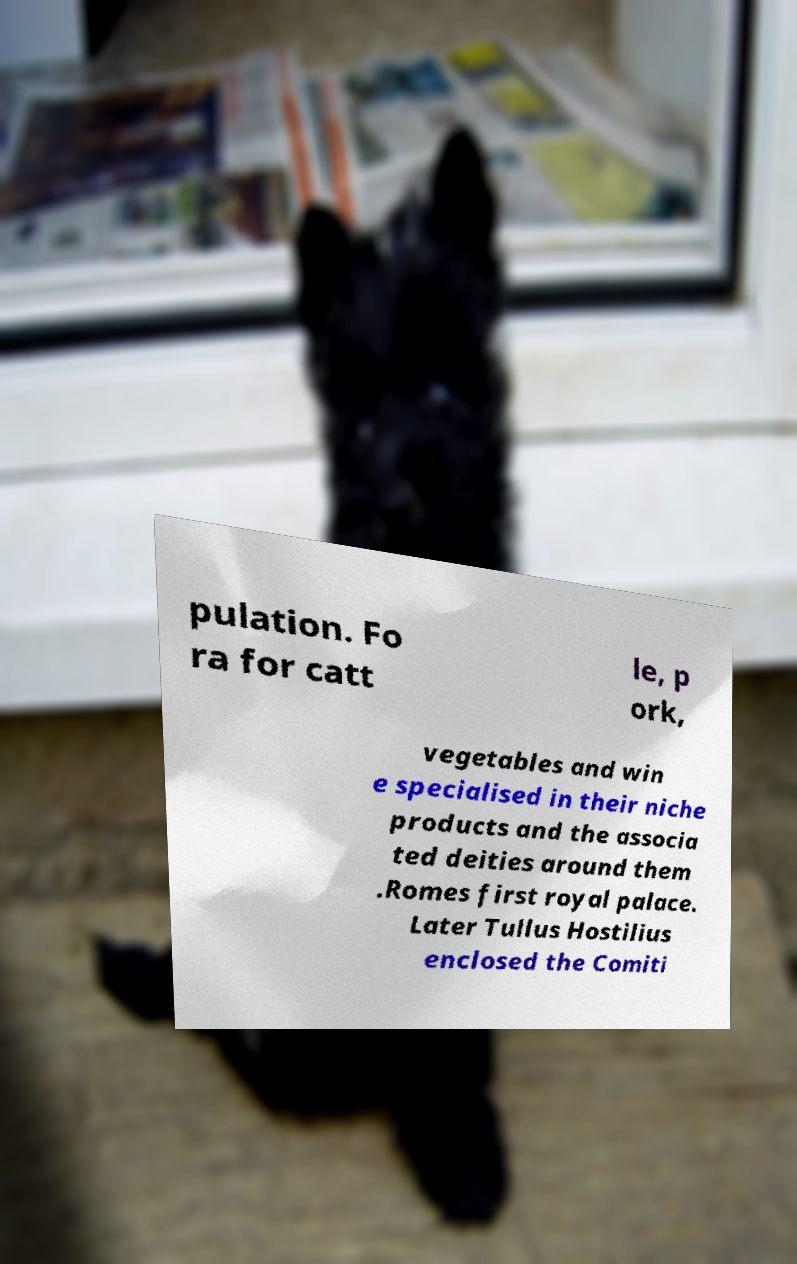Could you extract and type out the text from this image? pulation. Fo ra for catt le, p ork, vegetables and win e specialised in their niche products and the associa ted deities around them .Romes first royal palace. Later Tullus Hostilius enclosed the Comiti 